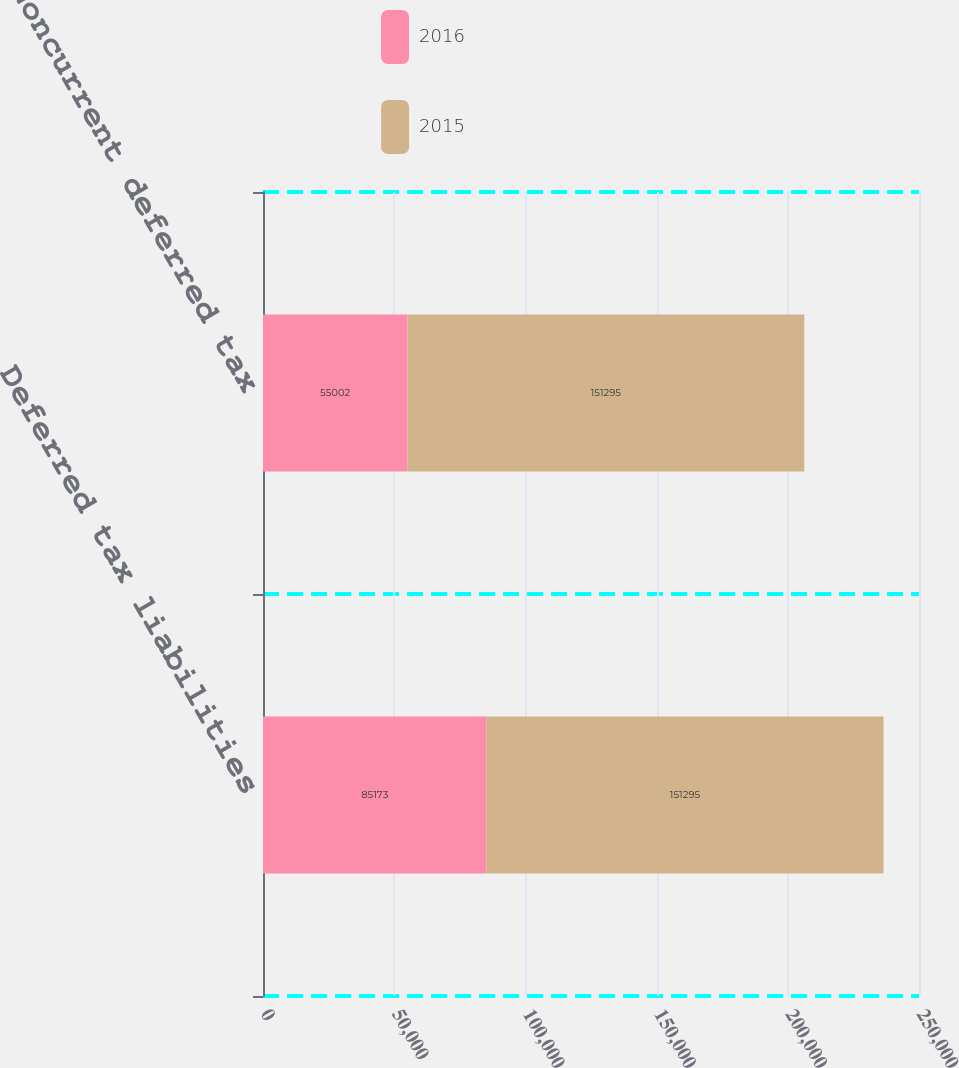Convert chart to OTSL. <chart><loc_0><loc_0><loc_500><loc_500><stacked_bar_chart><ecel><fcel>Deferred tax liabilities<fcel>Noncurrent deferred tax<nl><fcel>2016<fcel>85173<fcel>55002<nl><fcel>2015<fcel>151295<fcel>151295<nl></chart> 